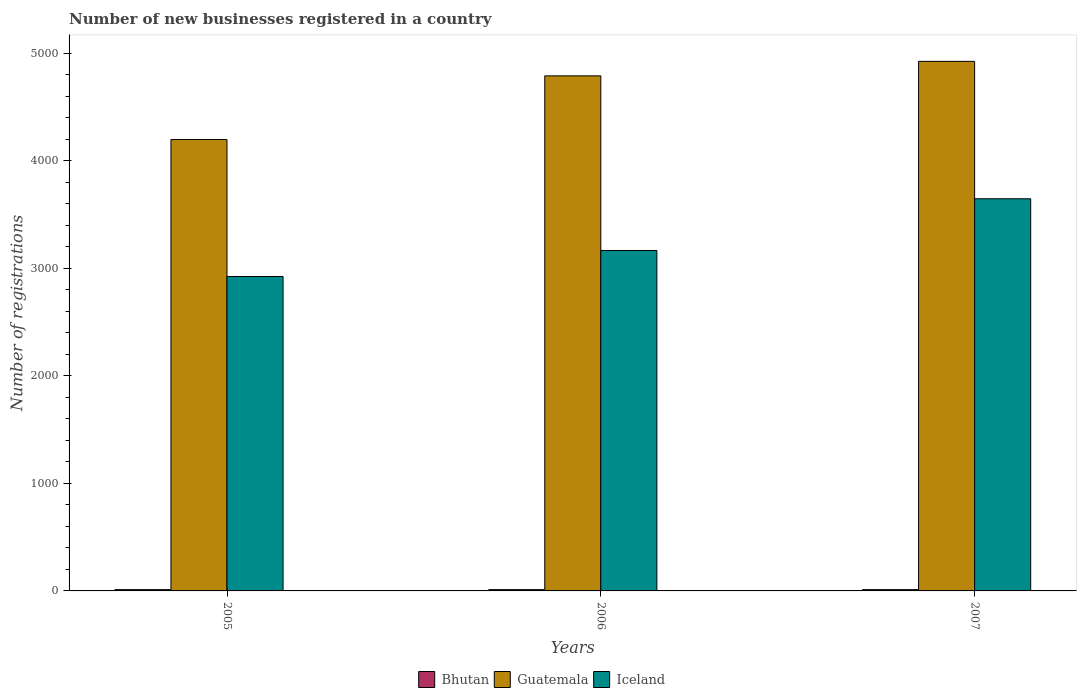How many groups of bars are there?
Offer a terse response. 3. Are the number of bars per tick equal to the number of legend labels?
Ensure brevity in your answer.  Yes. Are the number of bars on each tick of the X-axis equal?
Offer a very short reply. Yes. What is the label of the 3rd group of bars from the left?
Your response must be concise. 2007. In how many cases, is the number of bars for a given year not equal to the number of legend labels?
Your answer should be very brief. 0. What is the number of new businesses registered in Guatemala in 2006?
Ensure brevity in your answer.  4790. Across all years, what is the minimum number of new businesses registered in Iceland?
Offer a very short reply. 2924. In which year was the number of new businesses registered in Iceland maximum?
Your answer should be compact. 2007. What is the difference between the number of new businesses registered in Iceland in 2006 and that in 2007?
Keep it short and to the point. -481. What is the difference between the number of new businesses registered in Bhutan in 2007 and the number of new businesses registered in Guatemala in 2006?
Your answer should be compact. -4778. What is the average number of new businesses registered in Guatemala per year?
Offer a very short reply. 4637.67. In the year 2007, what is the difference between the number of new businesses registered in Bhutan and number of new businesses registered in Guatemala?
Ensure brevity in your answer.  -4913. What is the ratio of the number of new businesses registered in Bhutan in 2005 to that in 2007?
Ensure brevity in your answer.  1. Is the difference between the number of new businesses registered in Bhutan in 2006 and 2007 greater than the difference between the number of new businesses registered in Guatemala in 2006 and 2007?
Ensure brevity in your answer.  Yes. What is the difference between the highest and the second highest number of new businesses registered in Iceland?
Provide a succinct answer. 481. In how many years, is the number of new businesses registered in Iceland greater than the average number of new businesses registered in Iceland taken over all years?
Provide a short and direct response. 1. Is the sum of the number of new businesses registered in Bhutan in 2006 and 2007 greater than the maximum number of new businesses registered in Iceland across all years?
Give a very brief answer. No. What does the 2nd bar from the left in 2007 represents?
Ensure brevity in your answer.  Guatemala. What does the 3rd bar from the right in 2006 represents?
Give a very brief answer. Bhutan. Are all the bars in the graph horizontal?
Ensure brevity in your answer.  No. How many years are there in the graph?
Your response must be concise. 3. What is the difference between two consecutive major ticks on the Y-axis?
Provide a short and direct response. 1000. Where does the legend appear in the graph?
Your answer should be compact. Bottom center. What is the title of the graph?
Provide a short and direct response. Number of new businesses registered in a country. Does "El Salvador" appear as one of the legend labels in the graph?
Ensure brevity in your answer.  No. What is the label or title of the Y-axis?
Ensure brevity in your answer.  Number of registrations. What is the Number of registrations of Guatemala in 2005?
Make the answer very short. 4198. What is the Number of registrations in Iceland in 2005?
Ensure brevity in your answer.  2924. What is the Number of registrations of Bhutan in 2006?
Offer a very short reply. 12. What is the Number of registrations in Guatemala in 2006?
Make the answer very short. 4790. What is the Number of registrations of Iceland in 2006?
Ensure brevity in your answer.  3166. What is the Number of registrations of Guatemala in 2007?
Provide a succinct answer. 4925. What is the Number of registrations of Iceland in 2007?
Make the answer very short. 3647. Across all years, what is the maximum Number of registrations of Bhutan?
Offer a terse response. 12. Across all years, what is the maximum Number of registrations in Guatemala?
Ensure brevity in your answer.  4925. Across all years, what is the maximum Number of registrations of Iceland?
Your answer should be very brief. 3647. Across all years, what is the minimum Number of registrations of Guatemala?
Offer a terse response. 4198. Across all years, what is the minimum Number of registrations in Iceland?
Ensure brevity in your answer.  2924. What is the total Number of registrations in Bhutan in the graph?
Your answer should be compact. 36. What is the total Number of registrations of Guatemala in the graph?
Keep it short and to the point. 1.39e+04. What is the total Number of registrations of Iceland in the graph?
Offer a very short reply. 9737. What is the difference between the Number of registrations in Guatemala in 2005 and that in 2006?
Make the answer very short. -592. What is the difference between the Number of registrations in Iceland in 2005 and that in 2006?
Provide a succinct answer. -242. What is the difference between the Number of registrations of Guatemala in 2005 and that in 2007?
Give a very brief answer. -727. What is the difference between the Number of registrations of Iceland in 2005 and that in 2007?
Give a very brief answer. -723. What is the difference between the Number of registrations of Bhutan in 2006 and that in 2007?
Your answer should be compact. 0. What is the difference between the Number of registrations in Guatemala in 2006 and that in 2007?
Offer a terse response. -135. What is the difference between the Number of registrations in Iceland in 2006 and that in 2007?
Give a very brief answer. -481. What is the difference between the Number of registrations in Bhutan in 2005 and the Number of registrations in Guatemala in 2006?
Ensure brevity in your answer.  -4778. What is the difference between the Number of registrations in Bhutan in 2005 and the Number of registrations in Iceland in 2006?
Keep it short and to the point. -3154. What is the difference between the Number of registrations of Guatemala in 2005 and the Number of registrations of Iceland in 2006?
Provide a short and direct response. 1032. What is the difference between the Number of registrations in Bhutan in 2005 and the Number of registrations in Guatemala in 2007?
Make the answer very short. -4913. What is the difference between the Number of registrations of Bhutan in 2005 and the Number of registrations of Iceland in 2007?
Your answer should be very brief. -3635. What is the difference between the Number of registrations in Guatemala in 2005 and the Number of registrations in Iceland in 2007?
Make the answer very short. 551. What is the difference between the Number of registrations in Bhutan in 2006 and the Number of registrations in Guatemala in 2007?
Ensure brevity in your answer.  -4913. What is the difference between the Number of registrations in Bhutan in 2006 and the Number of registrations in Iceland in 2007?
Give a very brief answer. -3635. What is the difference between the Number of registrations of Guatemala in 2006 and the Number of registrations of Iceland in 2007?
Provide a succinct answer. 1143. What is the average Number of registrations of Guatemala per year?
Make the answer very short. 4637.67. What is the average Number of registrations of Iceland per year?
Ensure brevity in your answer.  3245.67. In the year 2005, what is the difference between the Number of registrations in Bhutan and Number of registrations in Guatemala?
Keep it short and to the point. -4186. In the year 2005, what is the difference between the Number of registrations of Bhutan and Number of registrations of Iceland?
Provide a short and direct response. -2912. In the year 2005, what is the difference between the Number of registrations of Guatemala and Number of registrations of Iceland?
Your response must be concise. 1274. In the year 2006, what is the difference between the Number of registrations in Bhutan and Number of registrations in Guatemala?
Give a very brief answer. -4778. In the year 2006, what is the difference between the Number of registrations of Bhutan and Number of registrations of Iceland?
Give a very brief answer. -3154. In the year 2006, what is the difference between the Number of registrations of Guatemala and Number of registrations of Iceland?
Provide a short and direct response. 1624. In the year 2007, what is the difference between the Number of registrations in Bhutan and Number of registrations in Guatemala?
Keep it short and to the point. -4913. In the year 2007, what is the difference between the Number of registrations in Bhutan and Number of registrations in Iceland?
Offer a very short reply. -3635. In the year 2007, what is the difference between the Number of registrations in Guatemala and Number of registrations in Iceland?
Make the answer very short. 1278. What is the ratio of the Number of registrations in Guatemala in 2005 to that in 2006?
Offer a terse response. 0.88. What is the ratio of the Number of registrations in Iceland in 2005 to that in 2006?
Ensure brevity in your answer.  0.92. What is the ratio of the Number of registrations in Bhutan in 2005 to that in 2007?
Provide a succinct answer. 1. What is the ratio of the Number of registrations of Guatemala in 2005 to that in 2007?
Offer a very short reply. 0.85. What is the ratio of the Number of registrations in Iceland in 2005 to that in 2007?
Your answer should be very brief. 0.8. What is the ratio of the Number of registrations of Guatemala in 2006 to that in 2007?
Keep it short and to the point. 0.97. What is the ratio of the Number of registrations in Iceland in 2006 to that in 2007?
Offer a terse response. 0.87. What is the difference between the highest and the second highest Number of registrations of Guatemala?
Your response must be concise. 135. What is the difference between the highest and the second highest Number of registrations in Iceland?
Your answer should be compact. 481. What is the difference between the highest and the lowest Number of registrations in Bhutan?
Keep it short and to the point. 0. What is the difference between the highest and the lowest Number of registrations in Guatemala?
Give a very brief answer. 727. What is the difference between the highest and the lowest Number of registrations of Iceland?
Provide a succinct answer. 723. 